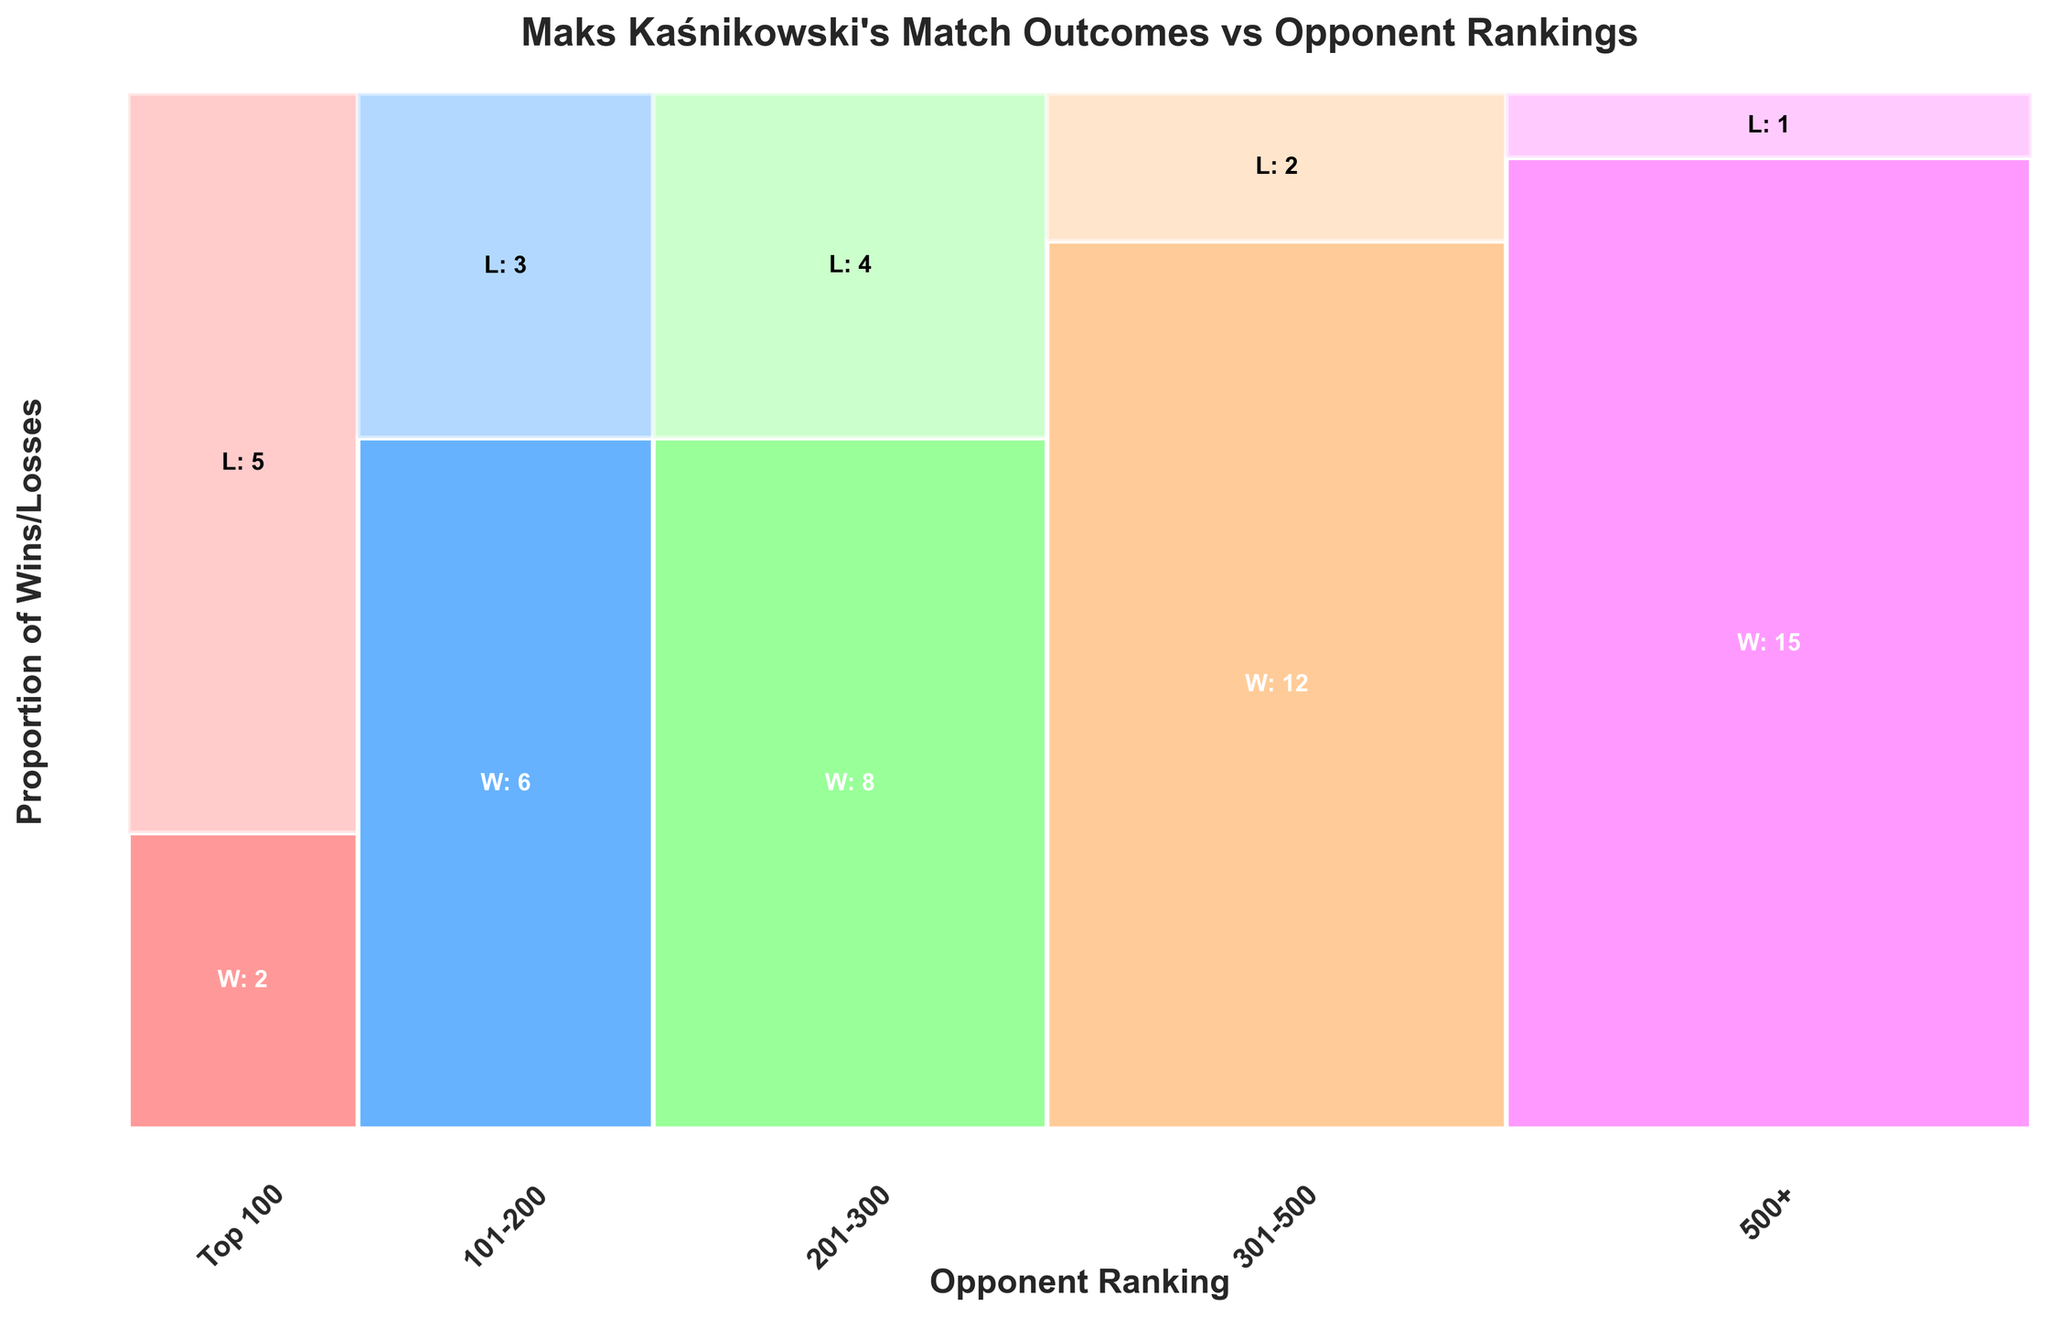What's the title of the figure? The title of the figure is usually found at the top and provides a brief description of what the figure represents.
Answer: "Maks Kaśnikowski's Match Outcomes vs Opponent Rankings" What is the proportion of matches against opponents ranked in the top 100? To find the proportion, add the number of wins and losses for opponents ranked in the top 100, then divide by the total number of matches. So, (2 + 5) / (2 + 5 + 6 + 3 + 8 + 4 + 12 + 2 + 15 + 1) = 7 / 58 ≈ 0.12.
Answer: Approximately 0.12 How many wins does Maks have against opponents ranked 201-300? Locate the section of the plot labeled "201-300" and look at the text indicating wins. The plot shows "W: 8" in the corresponding section.
Answer: 8 Which opponent ranking category has the highest proportion of losses? To find out, look for the section with the highest relative height of the loss portion (lighter-colored section). The "Top 100" section appears to have the highest proportion of losses.
Answer: Top 100 How does Maks's win rate change as opponent ranking decreases? Observing the plot from "Top 100" through "500+", the proportion of the win sections (darker color) increases as opponent ranking decreases, indicating a higher win rate with lower-ranked opponents.
Answer: Increases What is the total number of losses Maks has? Sum the losses from all ranking categories: 5 (Top 100) + 3 (101-200) + 4 (201-300) + 2 (301-500) + 1 (500+). So, 5 + 3 + 4 + 2 + 1 = 15.
Answer: 15 Compare the number of matches played against opponents ranked 301-500 with those ranked 201-300. Add wins and losses for both categories: 301-500 = 12 + 2 = 14 matches, 201-300 = 8 + 4 = 12 matches. So, 301-500 > 201-300.
Answer: More against 301-500 What's the average number of wins per category? To get the average, sum the wins across all categories and divide by the number of categories: (2 + 6 + 8 + 12 + 15) / 5 = 43 / 5 = 8.6.
Answer: 8.6 In which opponent ranking category does Maks have the highest number of wins? Locate the ranking category with the highest number indicated in the "W: " text. "500+" shows the highest wins with "W: 15."
Answer: 500+ What percentage of matches against the 500+ ranking category resulted in losses? To find the percentage, divide losses by the total matches in that category and multiply by 100%. So, 1 / (15 + 1) * 100% = 1 / 16 * 100% = 6.25%.
Answer: 6.25% 